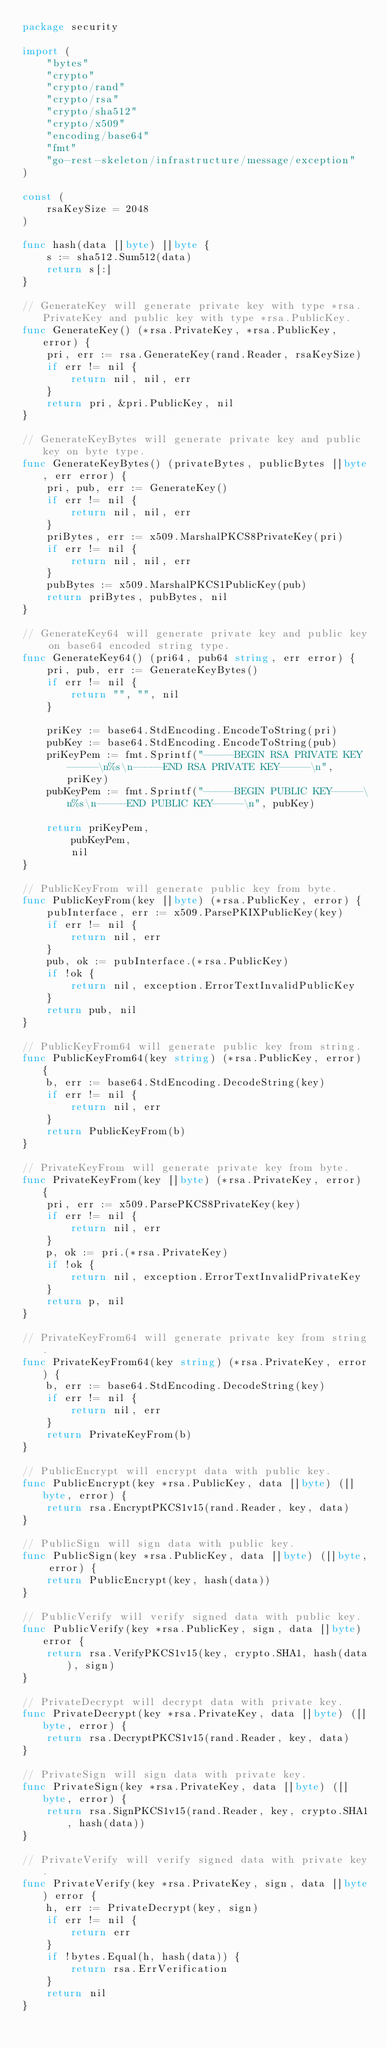<code> <loc_0><loc_0><loc_500><loc_500><_Go_>package security

import (
	"bytes"
	"crypto"
	"crypto/rand"
	"crypto/rsa"
	"crypto/sha512"
	"crypto/x509"
	"encoding/base64"
	"fmt"
	"go-rest-skeleton/infrastructure/message/exception"
)

const (
	rsaKeySize = 2048
)

func hash(data []byte) []byte {
	s := sha512.Sum512(data)
	return s[:]
}

// GenerateKey will generate private key with type *rsa.PrivateKey and public key with type *rsa.PublicKey.
func GenerateKey() (*rsa.PrivateKey, *rsa.PublicKey, error) {
	pri, err := rsa.GenerateKey(rand.Reader, rsaKeySize)
	if err != nil {
		return nil, nil, err
	}
	return pri, &pri.PublicKey, nil
}

// GenerateKeyBytes will generate private key and public key on byte type.
func GenerateKeyBytes() (privateBytes, publicBytes []byte, err error) {
	pri, pub, err := GenerateKey()
	if err != nil {
		return nil, nil, err
	}
	priBytes, err := x509.MarshalPKCS8PrivateKey(pri)
	if err != nil {
		return nil, nil, err
	}
	pubBytes := x509.MarshalPKCS1PublicKey(pub)
	return priBytes, pubBytes, nil
}

// GenerateKey64 will generate private key and public key on base64 encoded string type.
func GenerateKey64() (pri64, pub64 string, err error) {
	pri, pub, err := GenerateKeyBytes()
	if err != nil {
		return "", "", nil
	}

	priKey := base64.StdEncoding.EncodeToString(pri)
	pubKey := base64.StdEncoding.EncodeToString(pub)
	priKeyPem := fmt.Sprintf("-----BEGIN RSA PRIVATE KEY-----\n%s\n-----END RSA PRIVATE KEY-----\n", priKey)
	pubKeyPem := fmt.Sprintf("-----BEGIN PUBLIC KEY-----\n%s\n-----END PUBLIC KEY-----\n", pubKey)

	return priKeyPem,
		pubKeyPem,
		nil
}

// PublicKeyFrom will generate public key from byte.
func PublicKeyFrom(key []byte) (*rsa.PublicKey, error) {
	pubInterface, err := x509.ParsePKIXPublicKey(key)
	if err != nil {
		return nil, err
	}
	pub, ok := pubInterface.(*rsa.PublicKey)
	if !ok {
		return nil, exception.ErrorTextInvalidPublicKey
	}
	return pub, nil
}

// PublicKeyFrom64 will generate public key from string.
func PublicKeyFrom64(key string) (*rsa.PublicKey, error) {
	b, err := base64.StdEncoding.DecodeString(key)
	if err != nil {
		return nil, err
	}
	return PublicKeyFrom(b)
}

// PrivateKeyFrom will generate private key from byte.
func PrivateKeyFrom(key []byte) (*rsa.PrivateKey, error) {
	pri, err := x509.ParsePKCS8PrivateKey(key)
	if err != nil {
		return nil, err
	}
	p, ok := pri.(*rsa.PrivateKey)
	if !ok {
		return nil, exception.ErrorTextInvalidPrivateKey
	}
	return p, nil
}

// PrivateKeyFrom64 will generate private key from string.
func PrivateKeyFrom64(key string) (*rsa.PrivateKey, error) {
	b, err := base64.StdEncoding.DecodeString(key)
	if err != nil {
		return nil, err
	}
	return PrivateKeyFrom(b)
}

// PublicEncrypt will encrypt data with public key.
func PublicEncrypt(key *rsa.PublicKey, data []byte) ([]byte, error) {
	return rsa.EncryptPKCS1v15(rand.Reader, key, data)
}

// PublicSign will sign data with public key.
func PublicSign(key *rsa.PublicKey, data []byte) ([]byte, error) {
	return PublicEncrypt(key, hash(data))
}

// PublicVerify will verify signed data with public key.
func PublicVerify(key *rsa.PublicKey, sign, data []byte) error {
	return rsa.VerifyPKCS1v15(key, crypto.SHA1, hash(data), sign)
}

// PrivateDecrypt will decrypt data with private key.
func PrivateDecrypt(key *rsa.PrivateKey, data []byte) ([]byte, error) {
	return rsa.DecryptPKCS1v15(rand.Reader, key, data)
}

// PrivateSign will sign data with private key.
func PrivateSign(key *rsa.PrivateKey, data []byte) ([]byte, error) {
	return rsa.SignPKCS1v15(rand.Reader, key, crypto.SHA1, hash(data))
}

// PrivateVerify will verify signed data with private key.
func PrivateVerify(key *rsa.PrivateKey, sign, data []byte) error {
	h, err := PrivateDecrypt(key, sign)
	if err != nil {
		return err
	}
	if !bytes.Equal(h, hash(data)) {
		return rsa.ErrVerification
	}
	return nil
}
</code> 